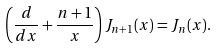<formula> <loc_0><loc_0><loc_500><loc_500>\left ( \frac { d } { d x } + \frac { n + 1 } { x } \right ) J _ { n + 1 } ( x ) = J _ { n } ( x ) .</formula> 